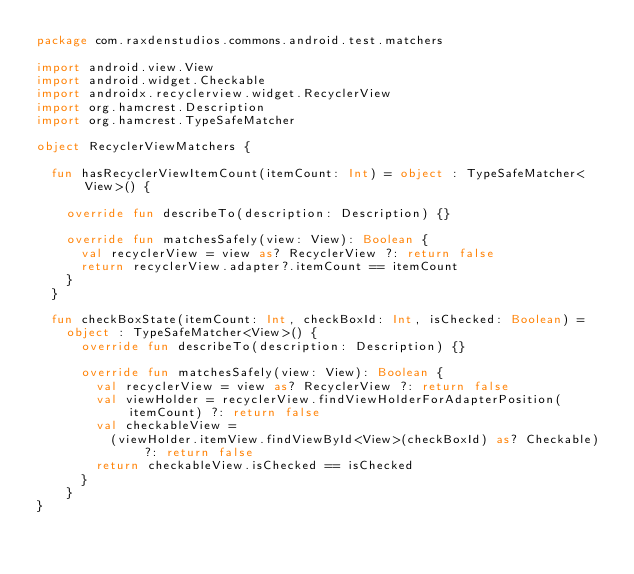Convert code to text. <code><loc_0><loc_0><loc_500><loc_500><_Kotlin_>package com.raxdenstudios.commons.android.test.matchers

import android.view.View
import android.widget.Checkable
import androidx.recyclerview.widget.RecyclerView
import org.hamcrest.Description
import org.hamcrest.TypeSafeMatcher

object RecyclerViewMatchers {

  fun hasRecyclerViewItemCount(itemCount: Int) = object : TypeSafeMatcher<View>() {

    override fun describeTo(description: Description) {}

    override fun matchesSafely(view: View): Boolean {
      val recyclerView = view as? RecyclerView ?: return false
      return recyclerView.adapter?.itemCount == itemCount
    }
  }

  fun checkBoxState(itemCount: Int, checkBoxId: Int, isChecked: Boolean) =
    object : TypeSafeMatcher<View>() {
      override fun describeTo(description: Description) {}

      override fun matchesSafely(view: View): Boolean {
        val recyclerView = view as? RecyclerView ?: return false
        val viewHolder = recyclerView.findViewHolderForAdapterPosition(itemCount) ?: return false
        val checkableView =
          (viewHolder.itemView.findViewById<View>(checkBoxId) as? Checkable) ?: return false
        return checkableView.isChecked == isChecked
      }
    }
}
</code> 